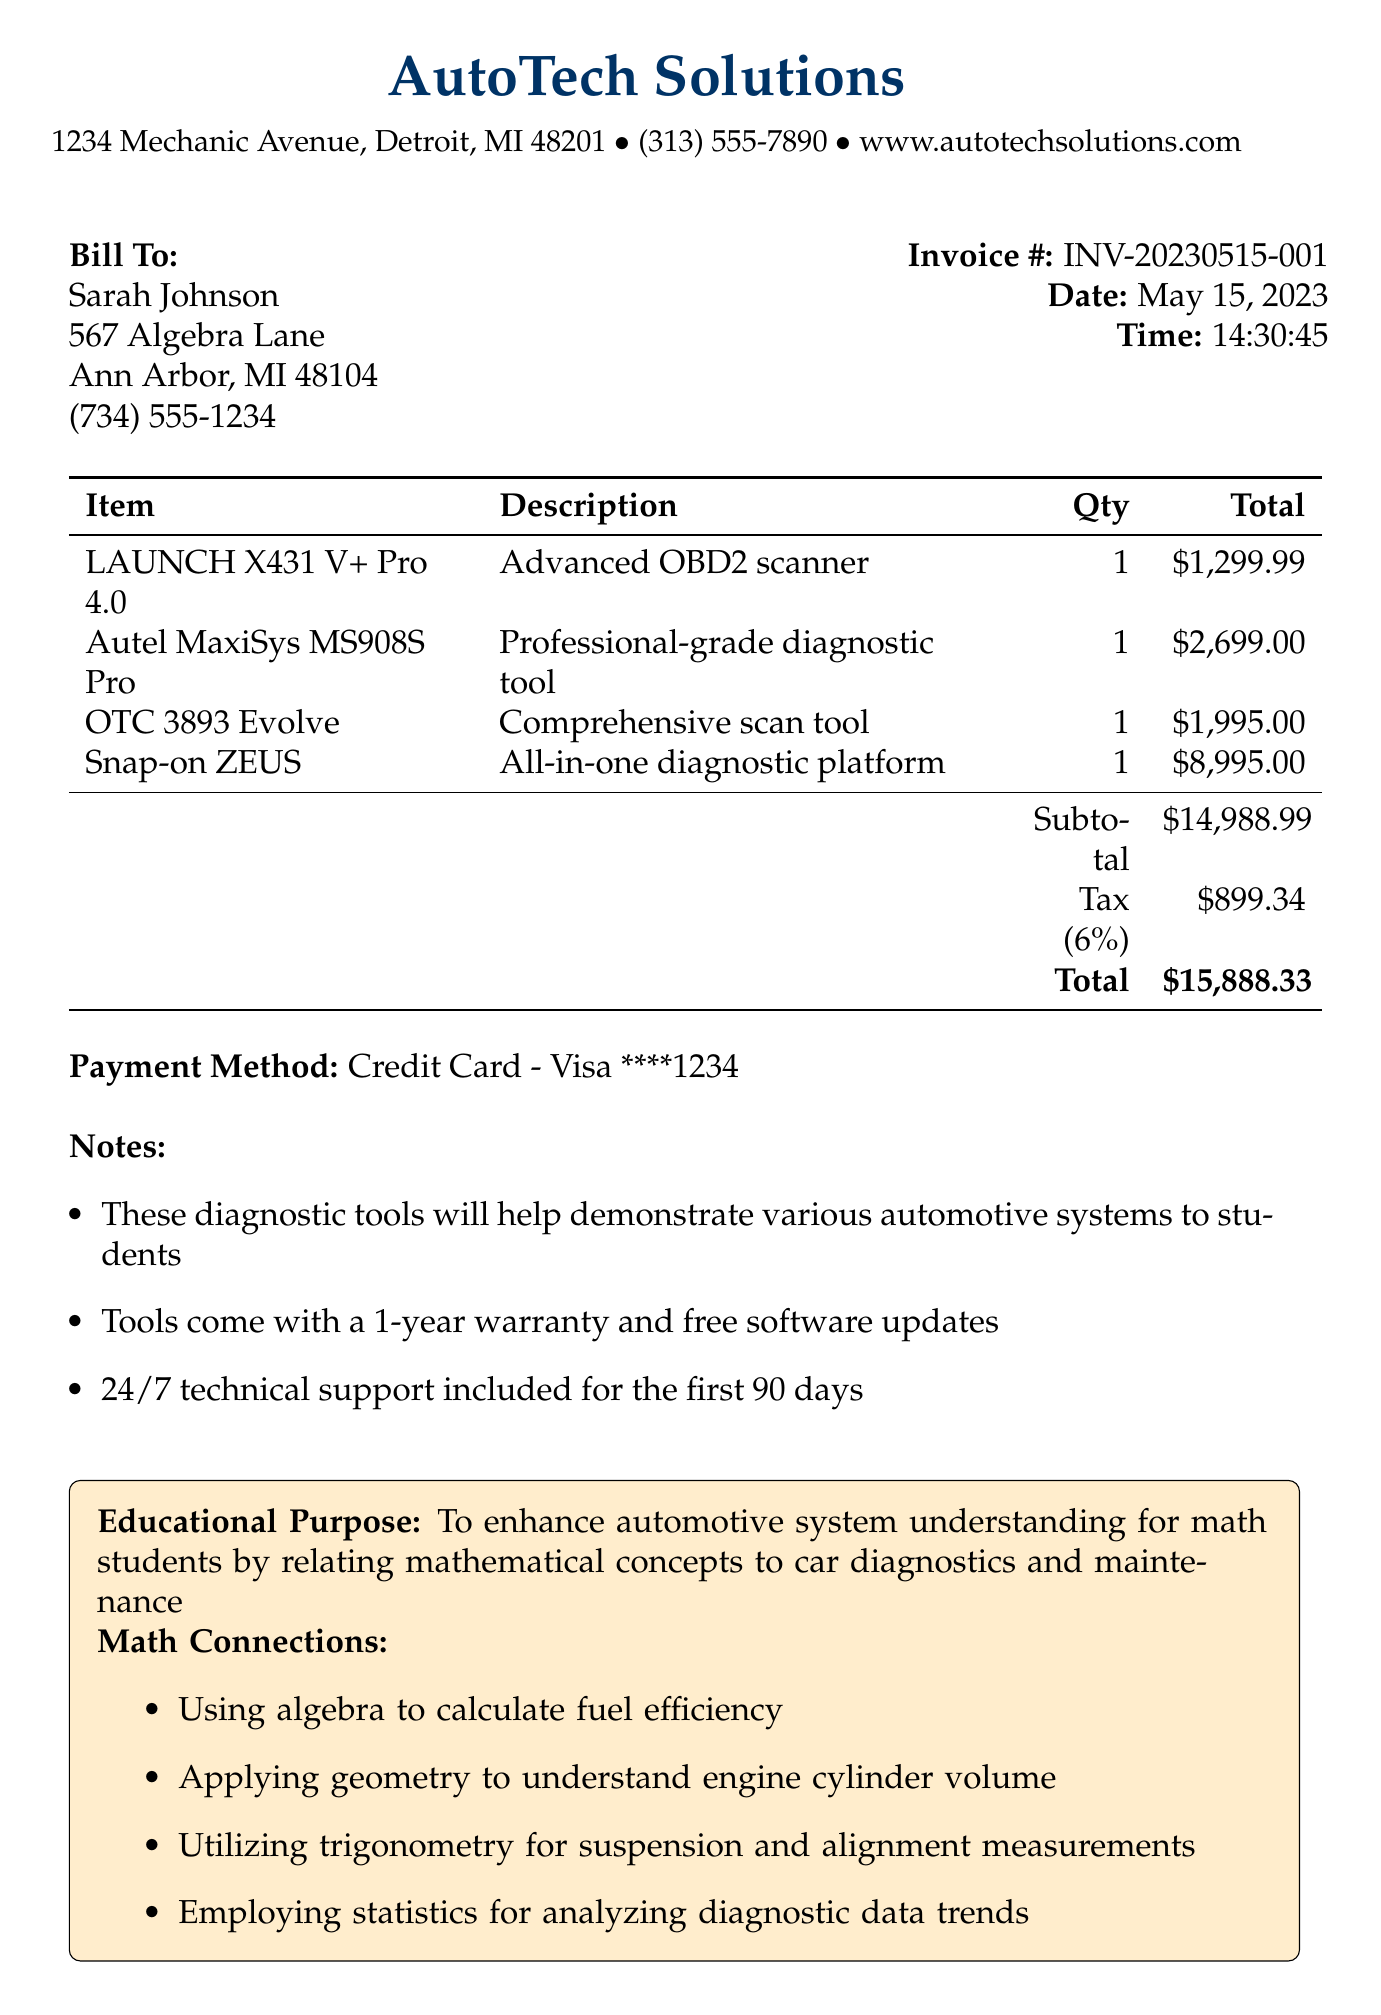What is the name of the merchant? The merchant's name is provided in the document, which is AutoTech Solutions.
Answer: AutoTech Solutions What is the total amount paid? The total amount is calculated at the end of the transaction document, which is $15,888.33.
Answer: $15,888.33 What is the date of the transaction? The date of the transaction is listed in the document as May 15, 2023.
Answer: May 15, 2023 How many diagnostic tools were purchased? The items section lists four diagnostic tools, indicating the quantity purchased is 4.
Answer: 4 What is the tax rate applied to the purchase? The document specifies the tax rate as 6%, indicating the amount charged for tax.
Answer: 6% What is included with the tools purchased? The notes section provides three key benefits that are included with the tools, stating they come with a 1-year warranty and free software updates.
Answer: 1-year warranty and free software updates What category do the tools enhance understanding of? The educational purpose section indicates the tools enhance understanding specifically for automotive systems.
Answer: Automotive systems Which payment method was used for the transaction? The payment method is clearly stated in the document as Credit Card - Visa ****1234.
Answer: Credit Card - Visa ****1234 